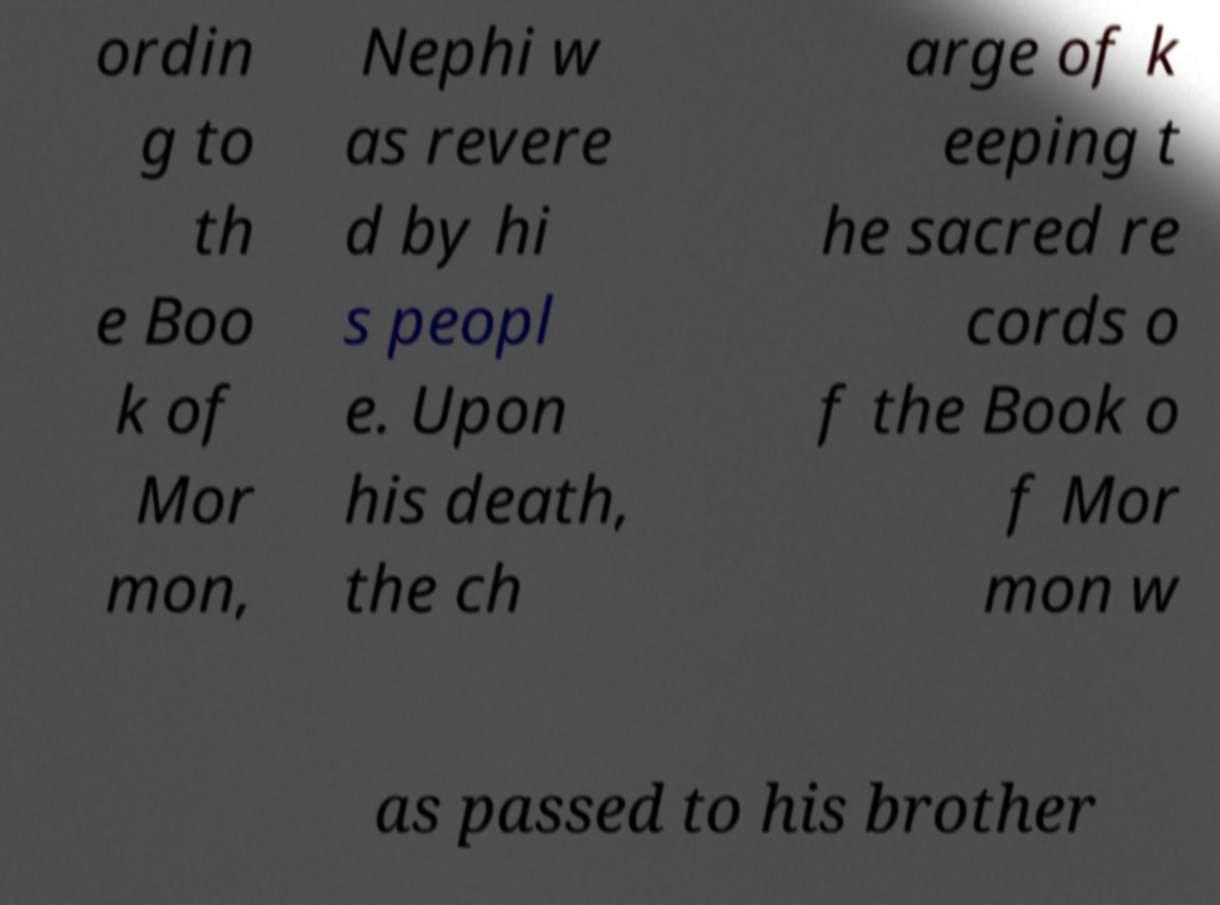Please identify and transcribe the text found in this image. ordin g to th e Boo k of Mor mon, Nephi w as revere d by hi s peopl e. Upon his death, the ch arge of k eeping t he sacred re cords o f the Book o f Mor mon w as passed to his brother 